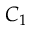Convert formula to latex. <formula><loc_0><loc_0><loc_500><loc_500>C _ { 1 }</formula> 